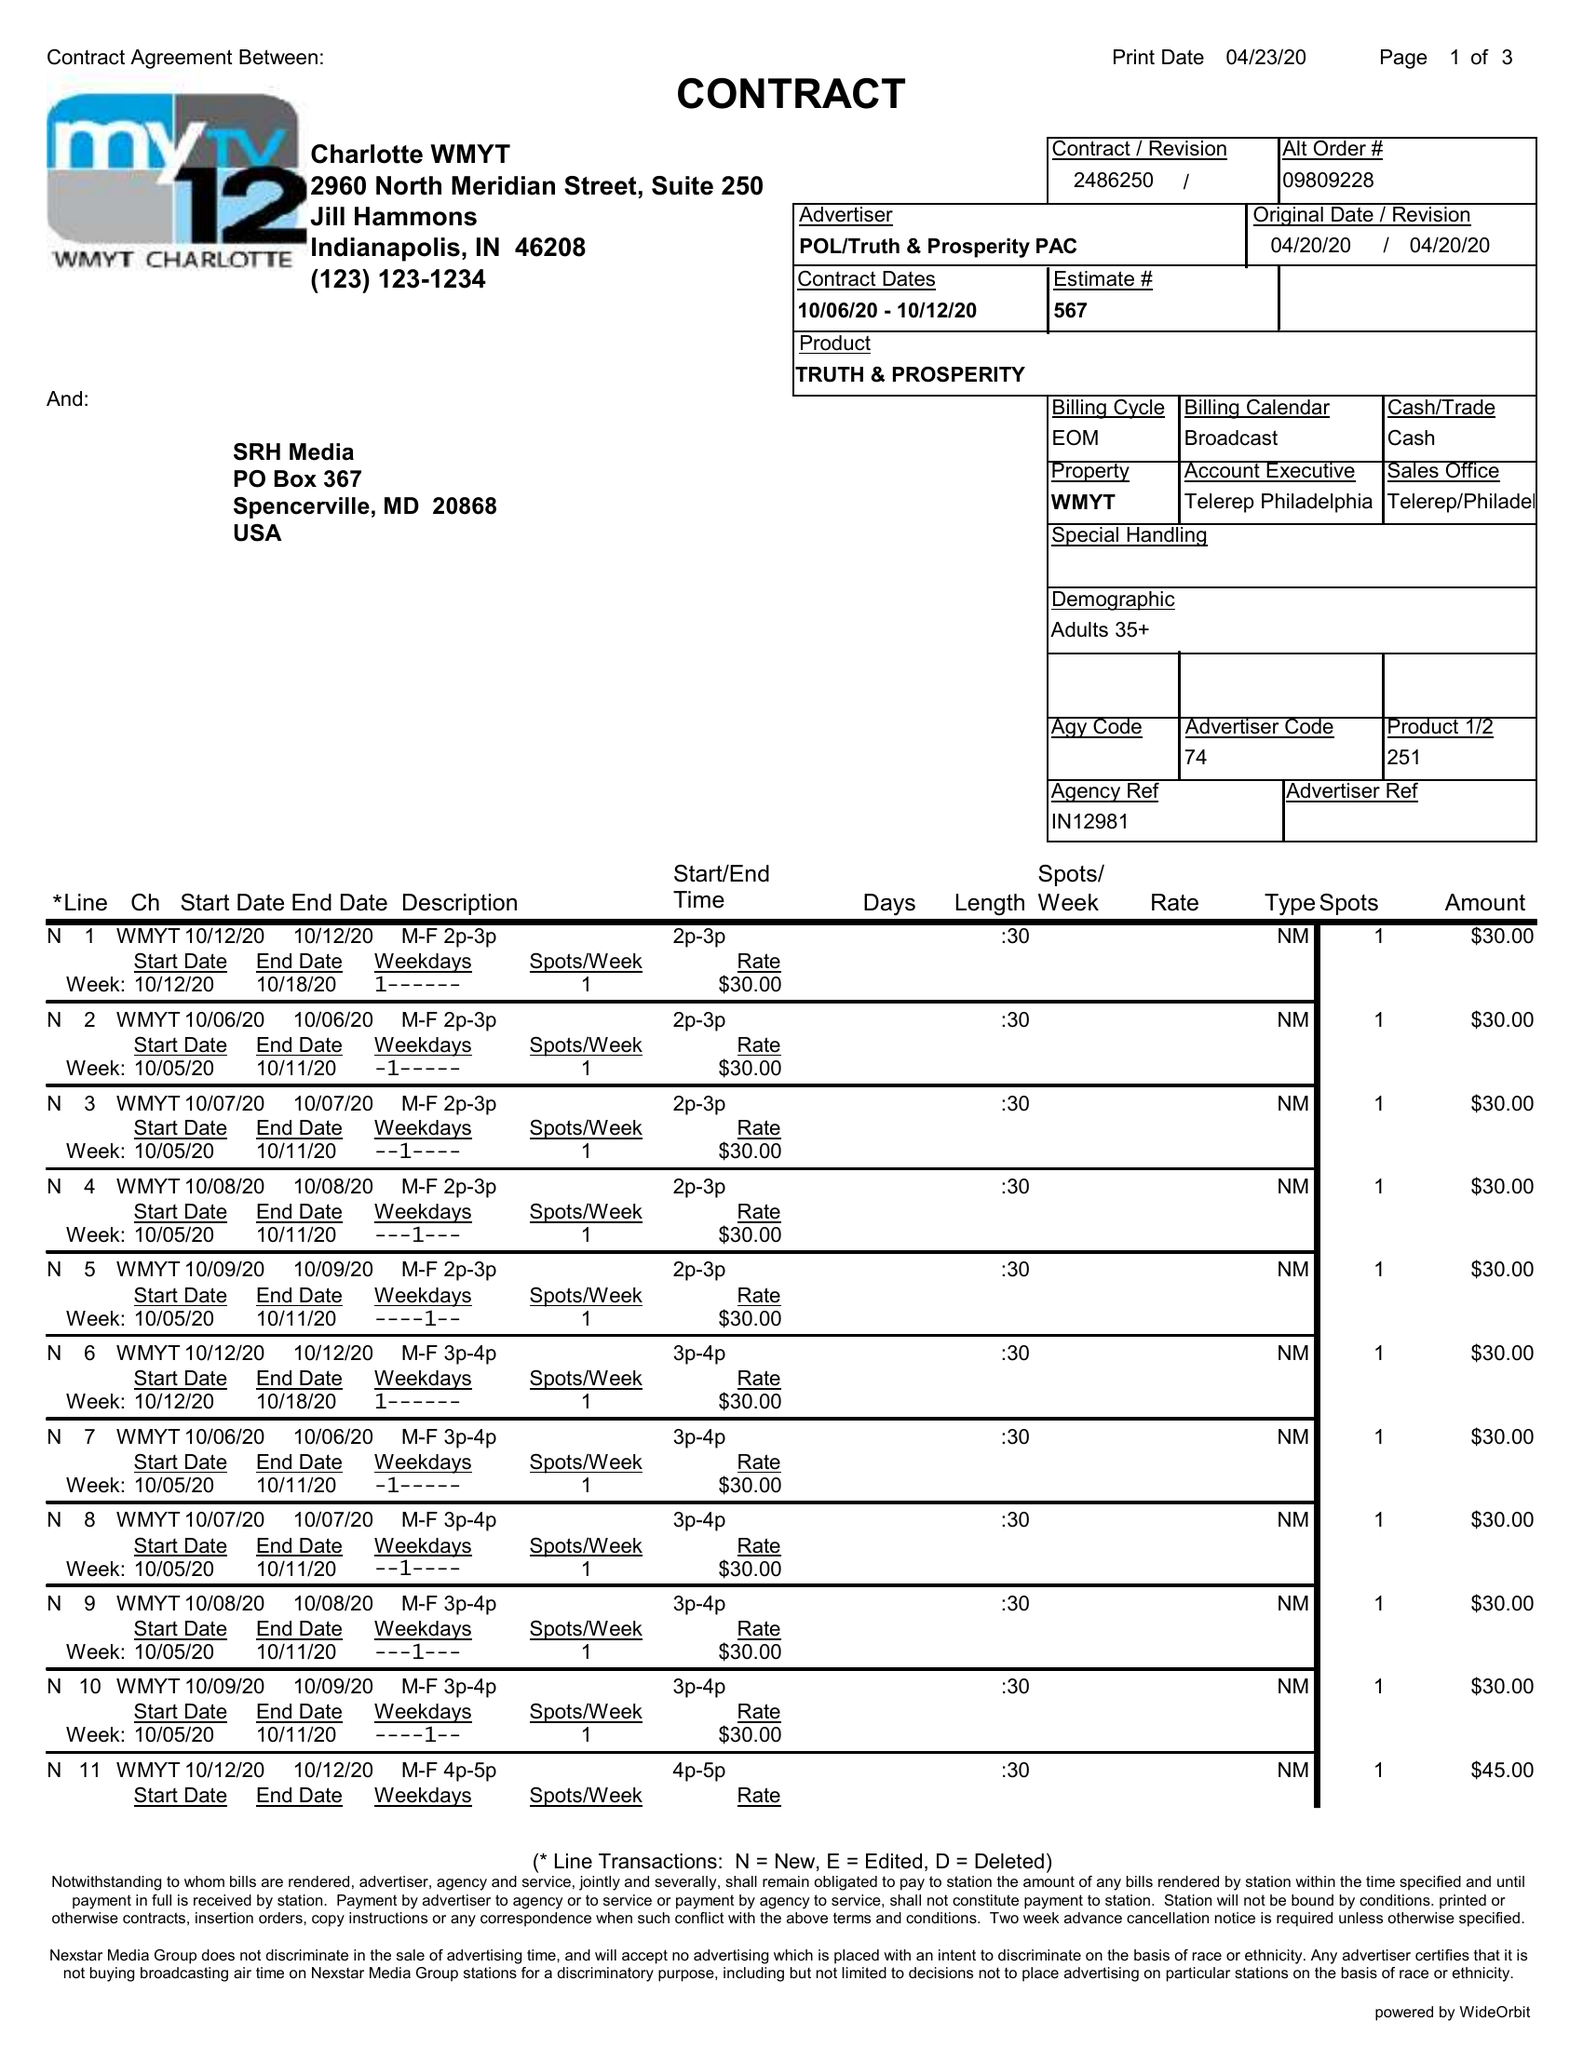What is the value for the contract_num?
Answer the question using a single word or phrase. 2486250 